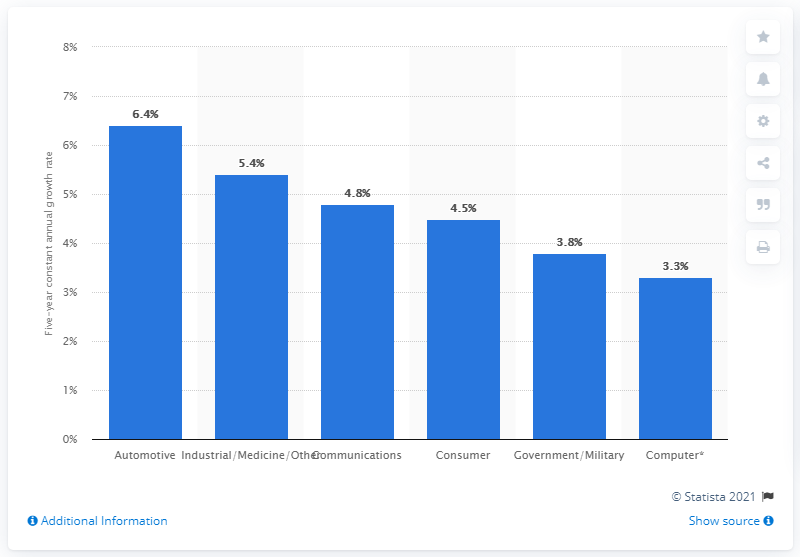List a handful of essential elements in this visual. The annual growth rate of the automotive industry is 6.4%. 